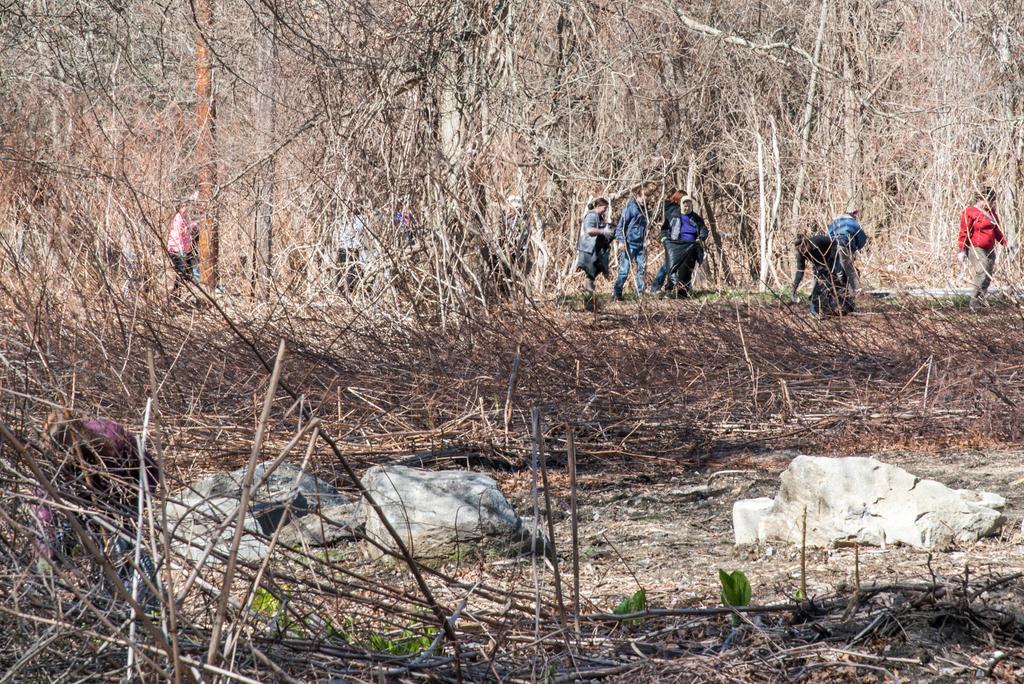Describe this image in one or two sentences. In this picture I can see rocks, there are group of people, and there are branches. 